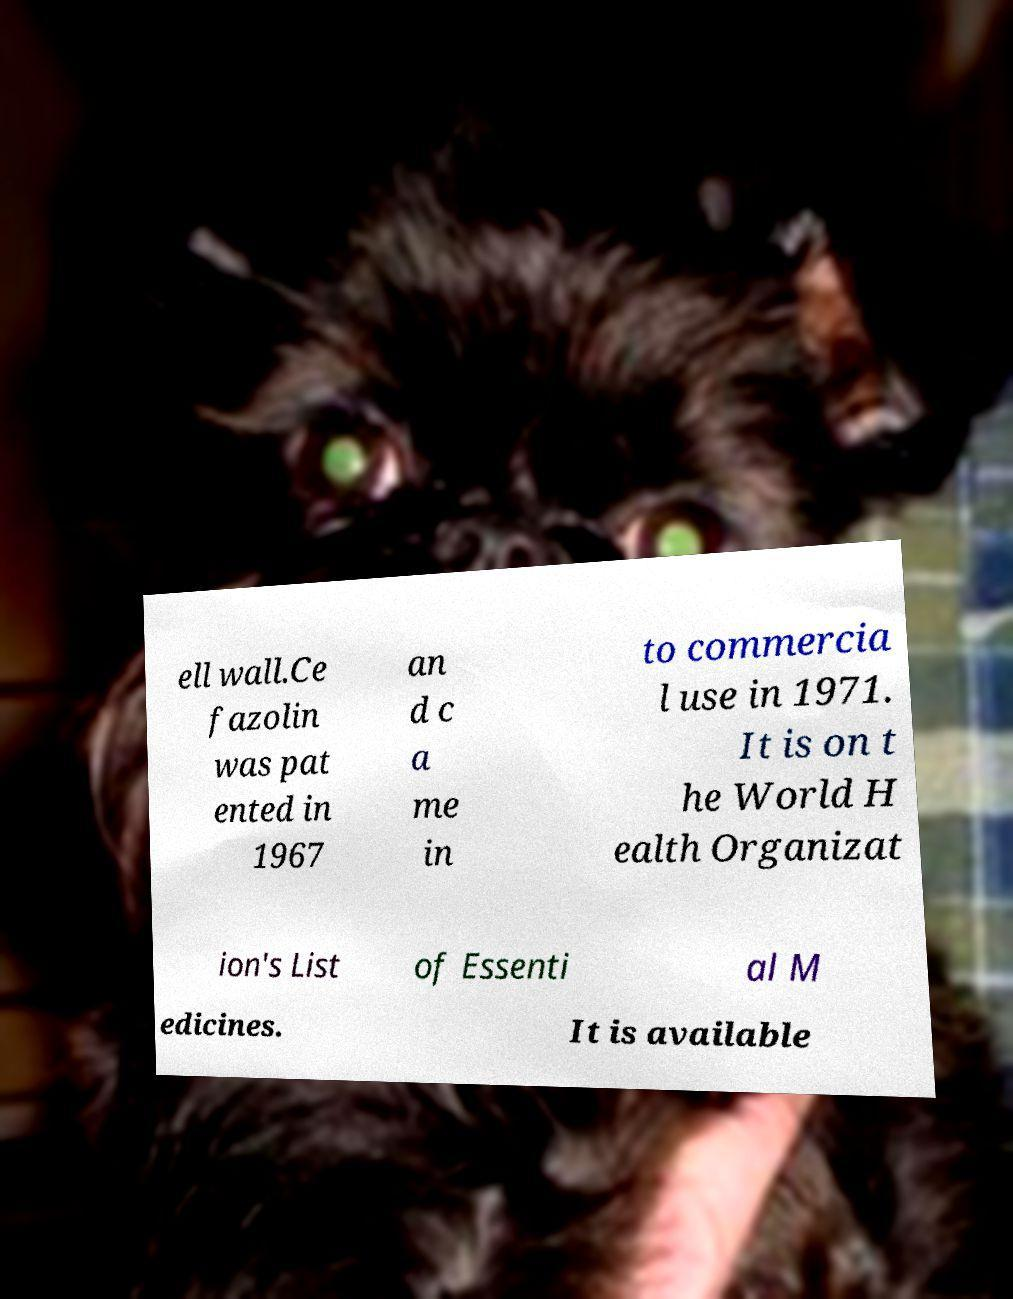Please read and relay the text visible in this image. What does it say? ell wall.Ce fazolin was pat ented in 1967 an d c a me in to commercia l use in 1971. It is on t he World H ealth Organizat ion's List of Essenti al M edicines. It is available 